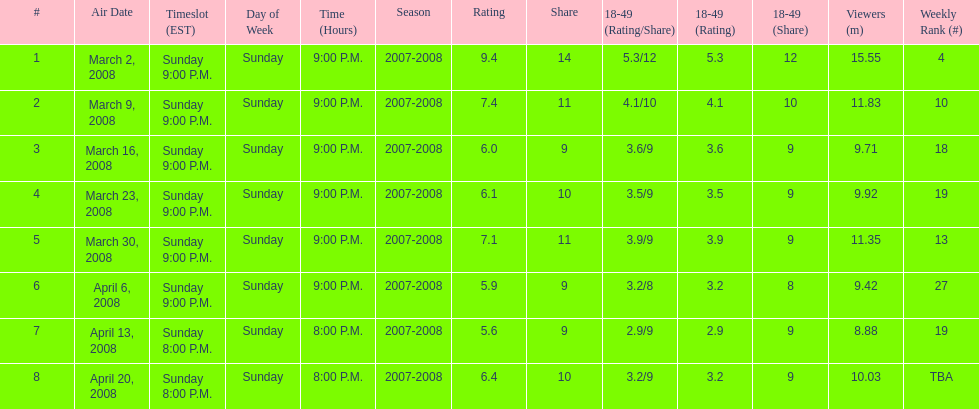What episode had the highest rating? March 2, 2008. 